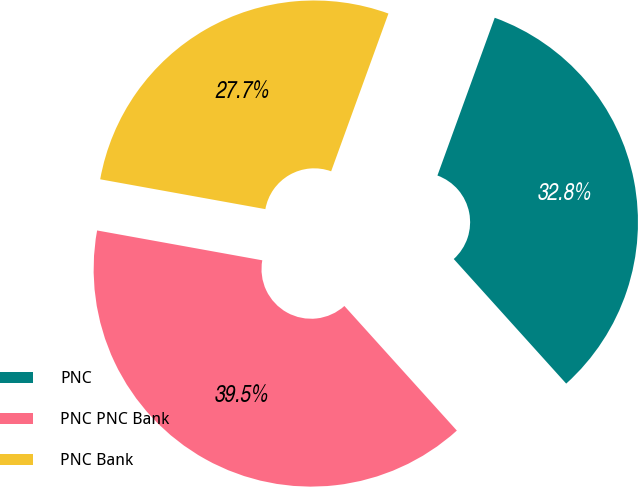Convert chart. <chart><loc_0><loc_0><loc_500><loc_500><pie_chart><fcel>PNC<fcel>PNC PNC Bank<fcel>PNC Bank<nl><fcel>32.77%<fcel>39.53%<fcel>27.7%<nl></chart> 